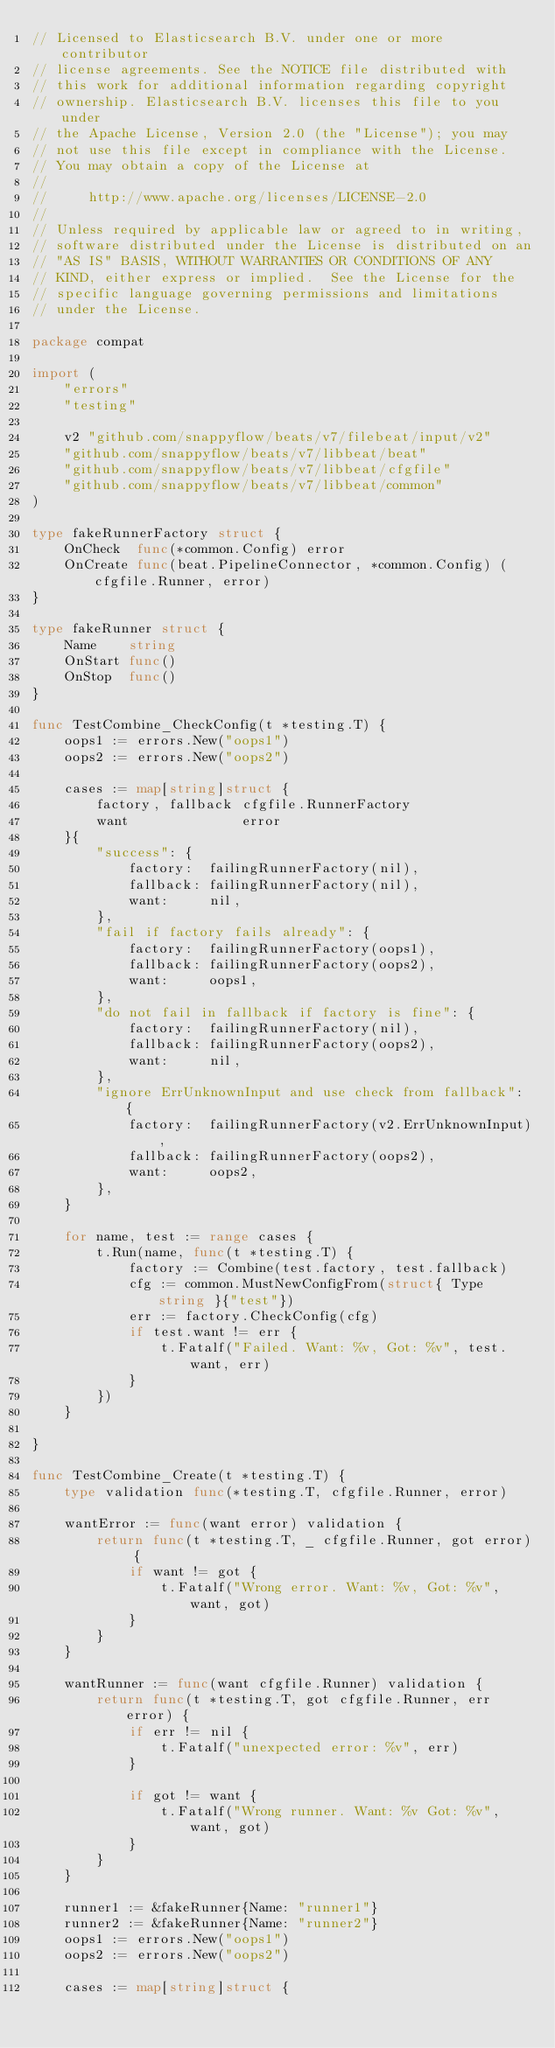<code> <loc_0><loc_0><loc_500><loc_500><_Go_>// Licensed to Elasticsearch B.V. under one or more contributor
// license agreements. See the NOTICE file distributed with
// this work for additional information regarding copyright
// ownership. Elasticsearch B.V. licenses this file to you under
// the Apache License, Version 2.0 (the "License"); you may
// not use this file except in compliance with the License.
// You may obtain a copy of the License at
//
//     http://www.apache.org/licenses/LICENSE-2.0
//
// Unless required by applicable law or agreed to in writing,
// software distributed under the License is distributed on an
// "AS IS" BASIS, WITHOUT WARRANTIES OR CONDITIONS OF ANY
// KIND, either express or implied.  See the License for the
// specific language governing permissions and limitations
// under the License.

package compat

import (
	"errors"
	"testing"

	v2 "github.com/snappyflow/beats/v7/filebeat/input/v2"
	"github.com/snappyflow/beats/v7/libbeat/beat"
	"github.com/snappyflow/beats/v7/libbeat/cfgfile"
	"github.com/snappyflow/beats/v7/libbeat/common"
)

type fakeRunnerFactory struct {
	OnCheck  func(*common.Config) error
	OnCreate func(beat.PipelineConnector, *common.Config) (cfgfile.Runner, error)
}

type fakeRunner struct {
	Name    string
	OnStart func()
	OnStop  func()
}

func TestCombine_CheckConfig(t *testing.T) {
	oops1 := errors.New("oops1")
	oops2 := errors.New("oops2")

	cases := map[string]struct {
		factory, fallback cfgfile.RunnerFactory
		want              error
	}{
		"success": {
			factory:  failingRunnerFactory(nil),
			fallback: failingRunnerFactory(nil),
			want:     nil,
		},
		"fail if factory fails already": {
			factory:  failingRunnerFactory(oops1),
			fallback: failingRunnerFactory(oops2),
			want:     oops1,
		},
		"do not fail in fallback if factory is fine": {
			factory:  failingRunnerFactory(nil),
			fallback: failingRunnerFactory(oops2),
			want:     nil,
		},
		"ignore ErrUnknownInput and use check from fallback": {
			factory:  failingRunnerFactory(v2.ErrUnknownInput),
			fallback: failingRunnerFactory(oops2),
			want:     oops2,
		},
	}

	for name, test := range cases {
		t.Run(name, func(t *testing.T) {
			factory := Combine(test.factory, test.fallback)
			cfg := common.MustNewConfigFrom(struct{ Type string }{"test"})
			err := factory.CheckConfig(cfg)
			if test.want != err {
				t.Fatalf("Failed. Want: %v, Got: %v", test.want, err)
			}
		})
	}

}

func TestCombine_Create(t *testing.T) {
	type validation func(*testing.T, cfgfile.Runner, error)

	wantError := func(want error) validation {
		return func(t *testing.T, _ cfgfile.Runner, got error) {
			if want != got {
				t.Fatalf("Wrong error. Want: %v, Got: %v", want, got)
			}
		}
	}

	wantRunner := func(want cfgfile.Runner) validation {
		return func(t *testing.T, got cfgfile.Runner, err error) {
			if err != nil {
				t.Fatalf("unexpected error: %v", err)
			}

			if got != want {
				t.Fatalf("Wrong runner. Want: %v Got: %v", want, got)
			}
		}
	}

	runner1 := &fakeRunner{Name: "runner1"}
	runner2 := &fakeRunner{Name: "runner2"}
	oops1 := errors.New("oops1")
	oops2 := errors.New("oops2")

	cases := map[string]struct {</code> 